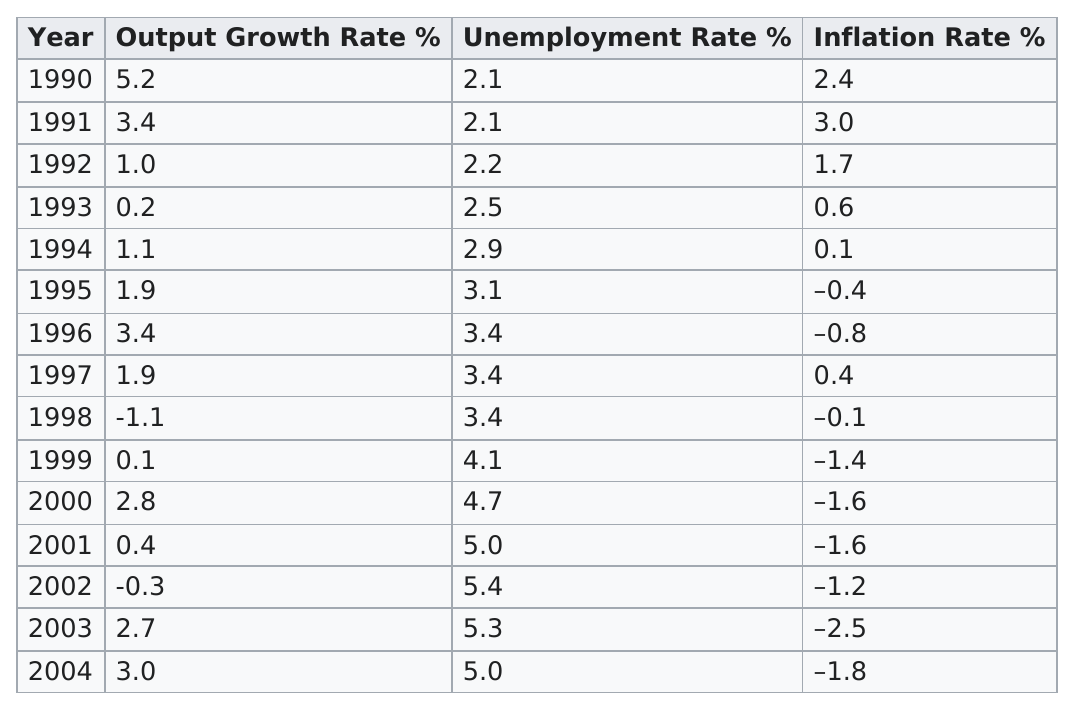Draw attention to some important aspects in this diagram. In the year 1990, Japan experienced the highest output growth rate among the years 1990 and 2004. In the year 2002, the unemployment rate was at its highest. During the period between 1990 and 2004, Japan experienced a negative inflation rate for a total of 9 years. The highest unemployment rates in Japan were recorded after the year 2000. Between 1990 and 2004, Japan's unemployment rate reached 5% or higher in four years. 